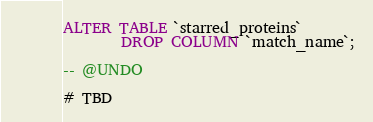Convert code to text. <code><loc_0><loc_0><loc_500><loc_500><_SQL_>ALTER TABLE `starred_proteins`
        DROP COLUMN `match_name`;

-- @UNDO

# TBD</code> 